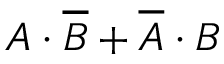<formula> <loc_0><loc_0><loc_500><loc_500>A \cdot { \overline { B } } + { \overline { A } } \cdot B</formula> 